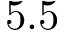Convert formula to latex. <formula><loc_0><loc_0><loc_500><loc_500>5 . 5</formula> 